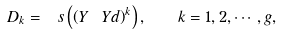Convert formula to latex. <formula><loc_0><loc_0><loc_500><loc_500>D _ { k } = \ s \left ( \left ( Y \ Y d \right ) ^ { k } \right ) , \quad k = 1 , 2 , \cdots , g ,</formula> 